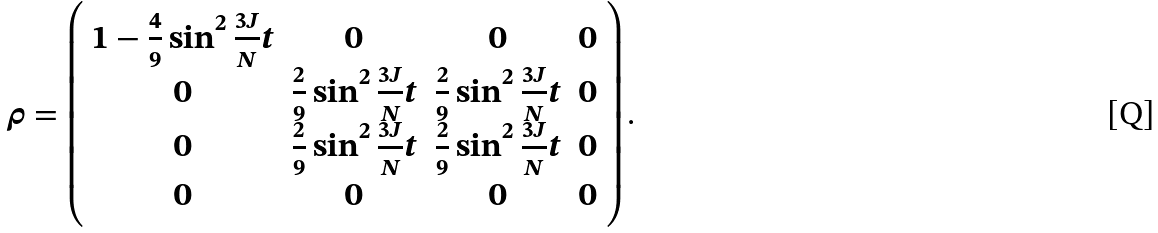Convert formula to latex. <formula><loc_0><loc_0><loc_500><loc_500>\rho = \left ( \begin{array} { c c c c } 1 - \frac { 4 } { 9 } \sin ^ { 2 } \frac { 3 J } { N } t & 0 & 0 & 0 \\ 0 & \frac { 2 } { 9 } \sin ^ { 2 } \frac { 3 J } { N } t & \frac { 2 } { 9 } \sin ^ { 2 } \frac { 3 J } { N } t & 0 \\ 0 & \frac { 2 } { 9 } \sin ^ { 2 } \frac { 3 J } { N } t & \frac { 2 } { 9 } \sin ^ { 2 } \frac { 3 J } { N } t & 0 \\ 0 & 0 & 0 & 0 \end{array} \right ) .</formula> 